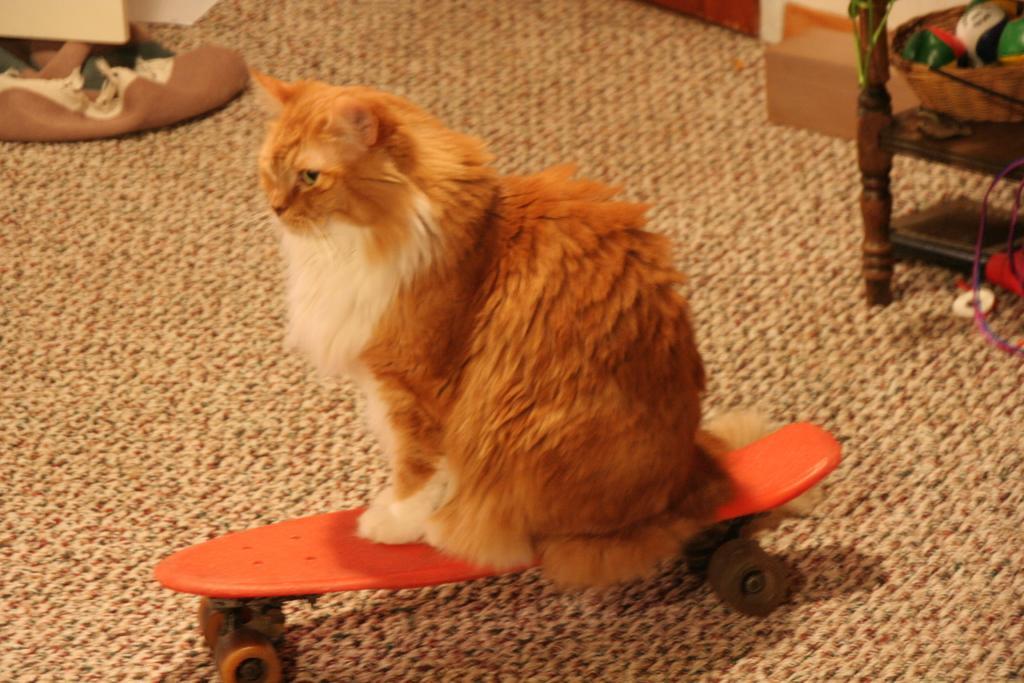Please provide a concise description of this image. In this image in front there is a cat on the skateboard. On the right side of the image there is a wooden rack. On top of it there are few objects. On the left side of the image there are few objects. At the bottom of the image there is a mat. 